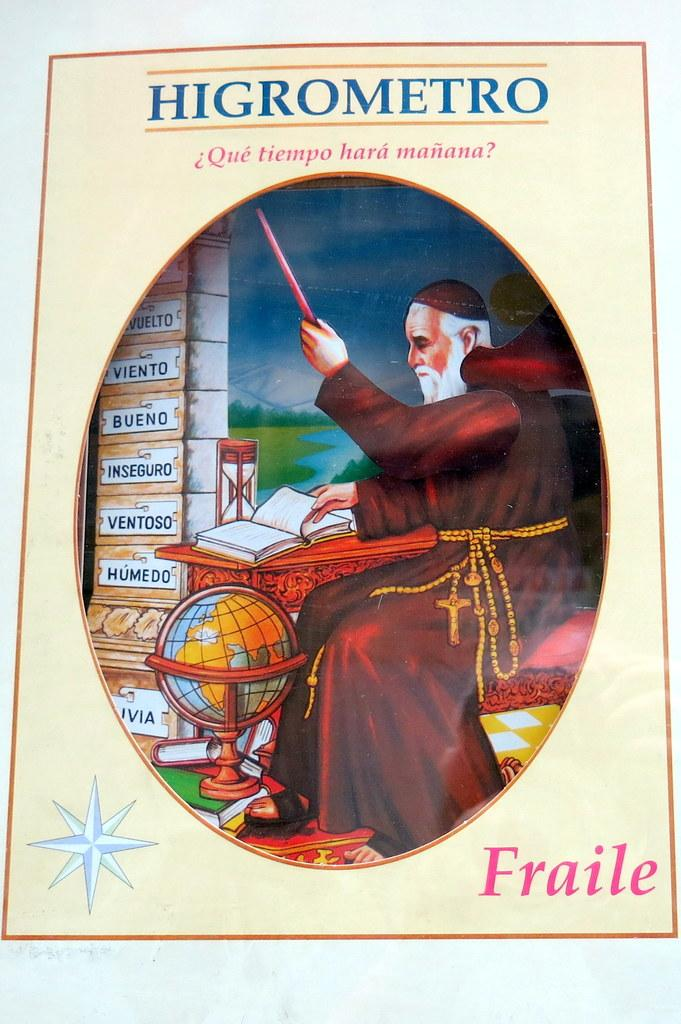What is the main subject of the image? The main subject of the image is a picture. What words can be seen on the picture? The word "HIGROMETRO" is at the top of the picture, and the word "FRAILE" is printed at the bottom of the picture. Who is depicted in the picture? There is an old man depicted in the picture. What type of houses can be seen in the background of the picture? There are no houses visible in the image; it only features the word "HIGROMETRO" at the top, the old man in the picture, and the word "FRAILE" at the bottom. What is the old man protesting in the image? There is no indication of a protest in the image; it simply shows an old man in a picture with the words "HIGROMETRO" and "FRAILE." 